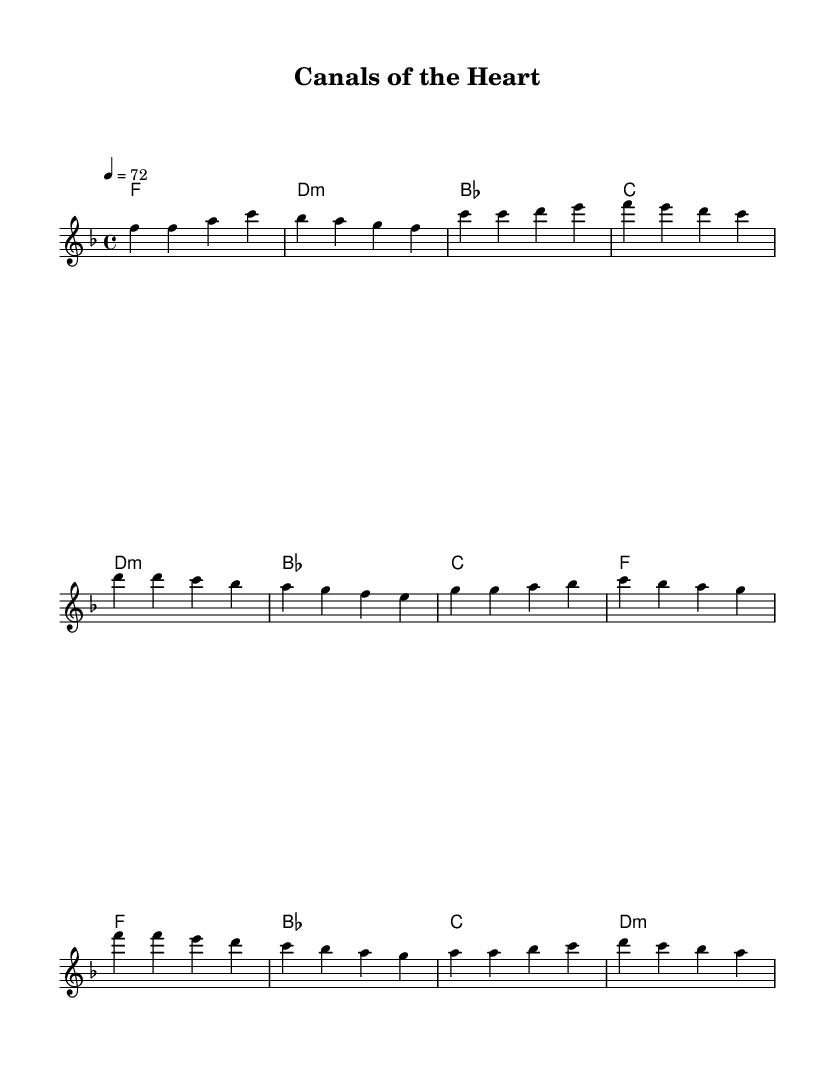What is the key signature of this music? The key signature is F major, which has one flat (B flat). You can identify the key signature by looking at the beginning of the staff; the flat sign indicates the key.
Answer: F major What is the time signature of the piece? The time signature displayed in the music sheet is 4/4, indicated at the beginning of the score. This denotes that each measure contains four beats, and each quarter note is one beat.
Answer: 4/4 What is the tempo of the piece? The tempo marking in the score indicates a speed of 72 beats per minute, noted at the beginning of the music. This means there are 72 quarter note beats in one minute.
Answer: 72 How many measures are there in the chorus? The chorus consists of four measures, which can be counted by identifying the separate bars in the music. The measures are distinctly marked by vertical lines.
Answer: 4 What type of chords are used in the pre-chorus? The pre-chorus utilizes minor harmony, specifically a D minor chord indicated at the beginning of the pre-chorus section and highlighted by the use of lowercase letters in chord names.
Answer: Minor Which section features the melody starting on a high note? The chorus features a melody that begins on a high note (F'), as indicated by the placement of the notes. It contrasts with the lower pitches present in the verse and pre-chorus.
Answer: Chorus What is the primary emotion conveyed by the harmony in this ballad? The harmony primarily conveys a sense of longing and nostalgia, typical of modern pop ballads, which often invoke emotional themes through their chord progressions and melody.
Answer: Longing 